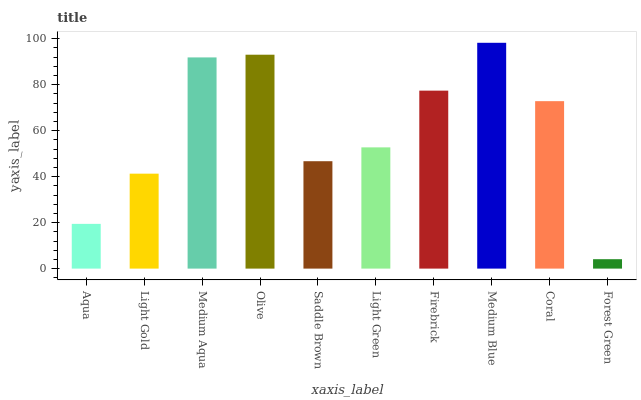Is Forest Green the minimum?
Answer yes or no. Yes. Is Medium Blue the maximum?
Answer yes or no. Yes. Is Light Gold the minimum?
Answer yes or no. No. Is Light Gold the maximum?
Answer yes or no. No. Is Light Gold greater than Aqua?
Answer yes or no. Yes. Is Aqua less than Light Gold?
Answer yes or no. Yes. Is Aqua greater than Light Gold?
Answer yes or no. No. Is Light Gold less than Aqua?
Answer yes or no. No. Is Coral the high median?
Answer yes or no. Yes. Is Light Green the low median?
Answer yes or no. Yes. Is Firebrick the high median?
Answer yes or no. No. Is Olive the low median?
Answer yes or no. No. 